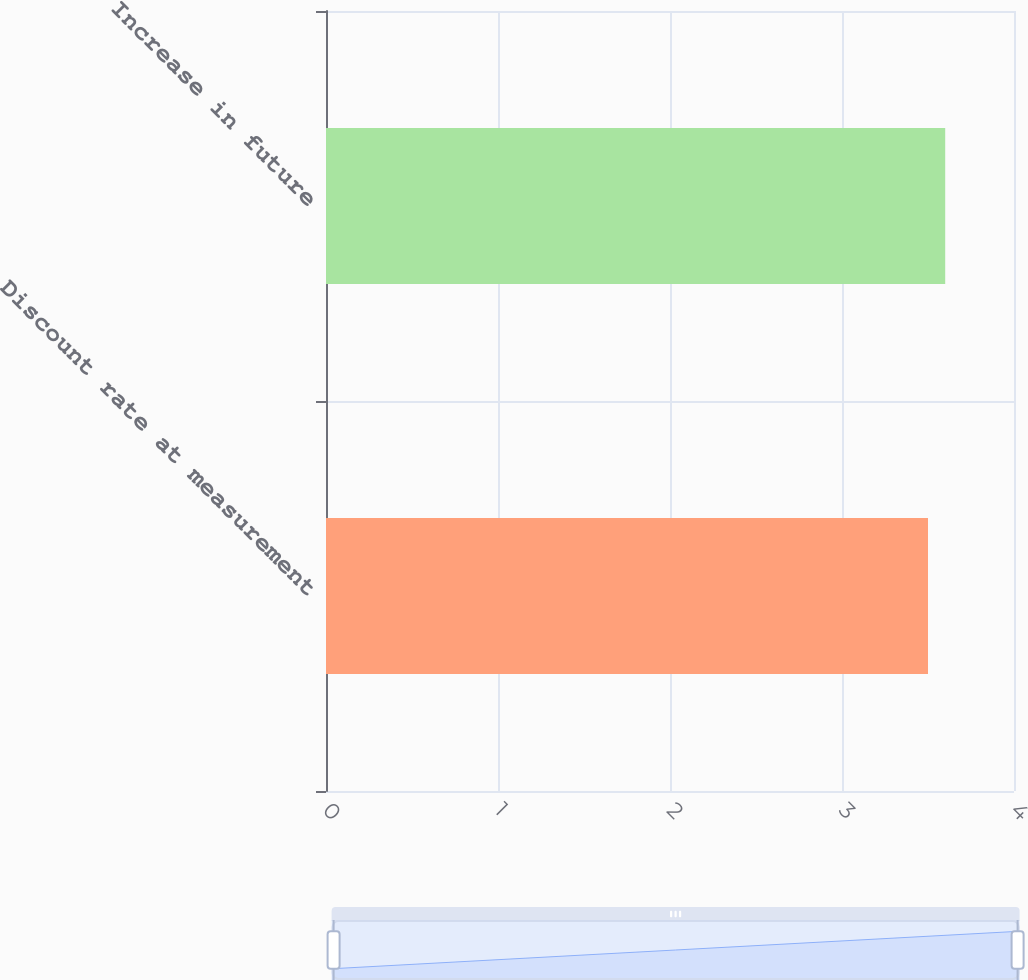<chart> <loc_0><loc_0><loc_500><loc_500><bar_chart><fcel>Discount rate at measurement<fcel>Increase in future<nl><fcel>3.5<fcel>3.6<nl></chart> 